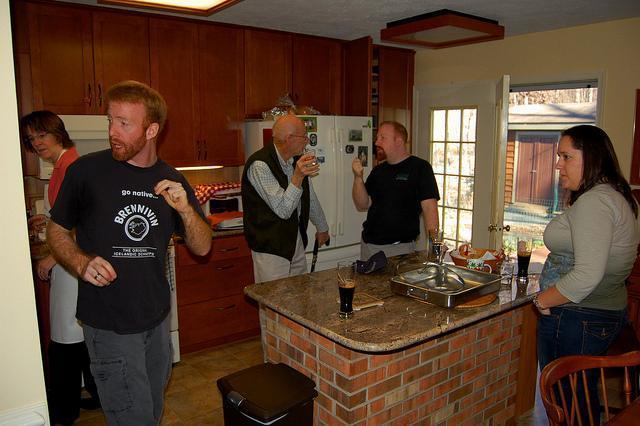How many people are wearing black?
Give a very brief answer. 3. How many people are visible?
Give a very brief answer. 5. 